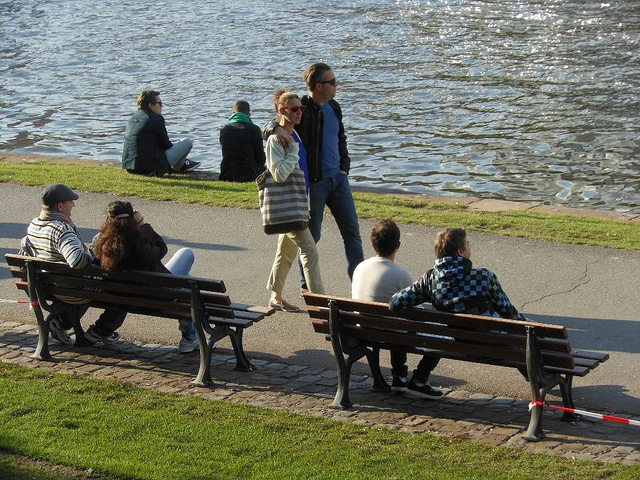Describe the objects in this image and their specific colors. I can see bench in darkgray, black, and gray tones, bench in darkgray, black, and gray tones, people in darkgray, black, navy, and gray tones, people in darkgray, black, gray, and navy tones, and people in darkgray, gray, and black tones in this image. 